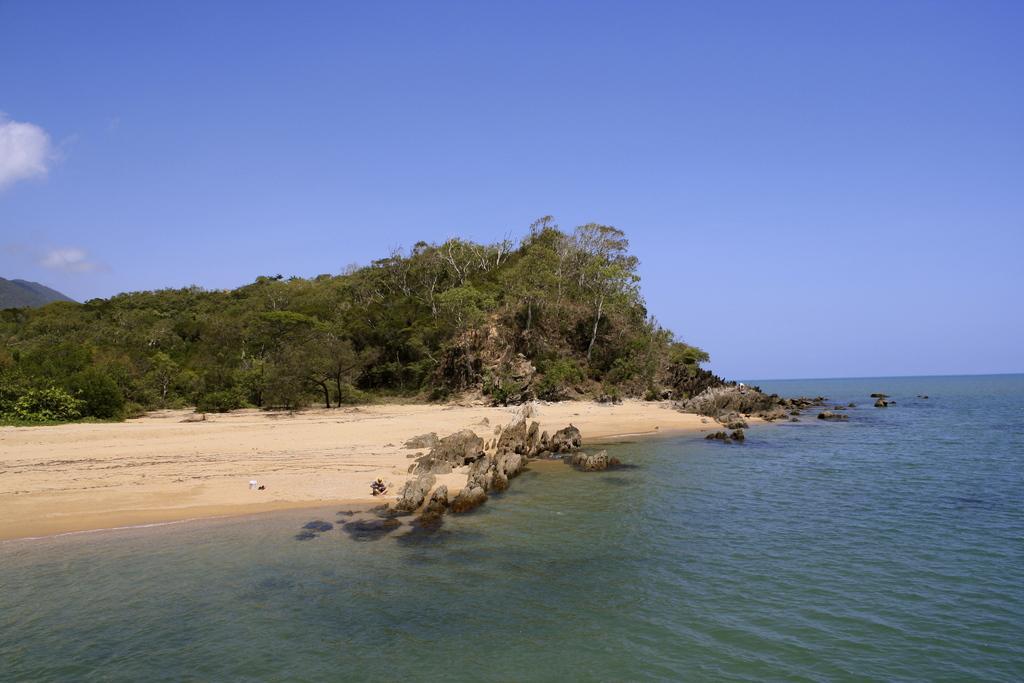Can you describe this image briefly? At the bottom we can see water,rocks and sand. In the background we can see trees,mountains on the left side and clouds in the sky. 